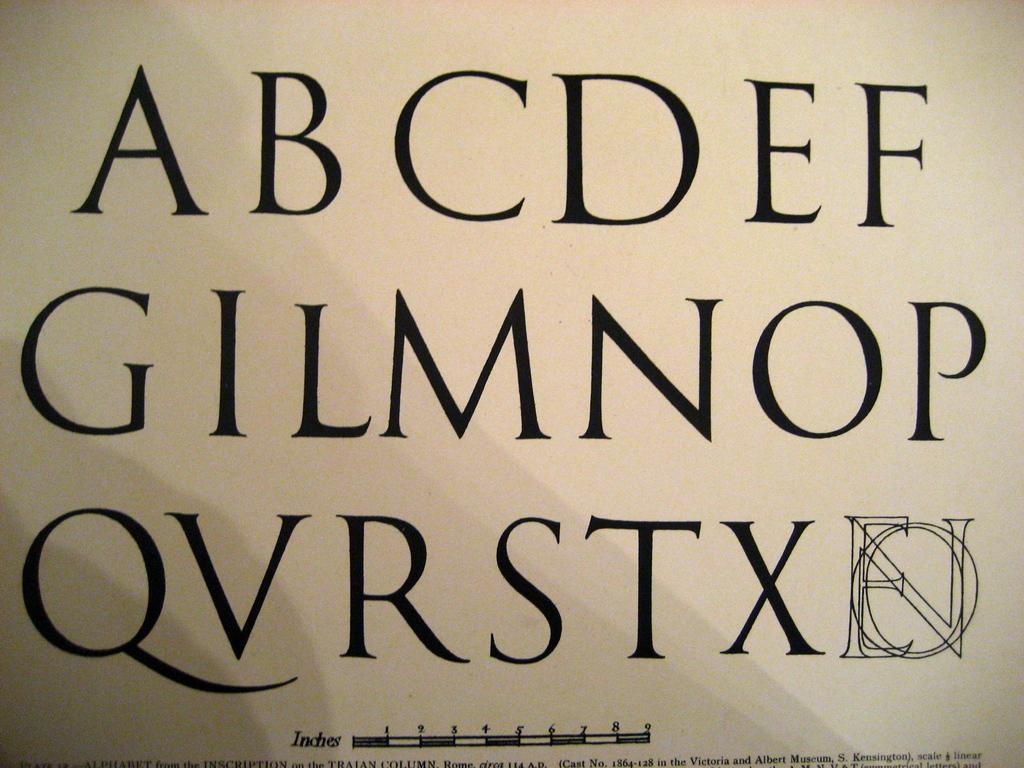What are the letters in the middle row?
Provide a succinct answer. Gilmnop. What are the letters in the bottom row?
Your response must be concise. Qvrstx. 